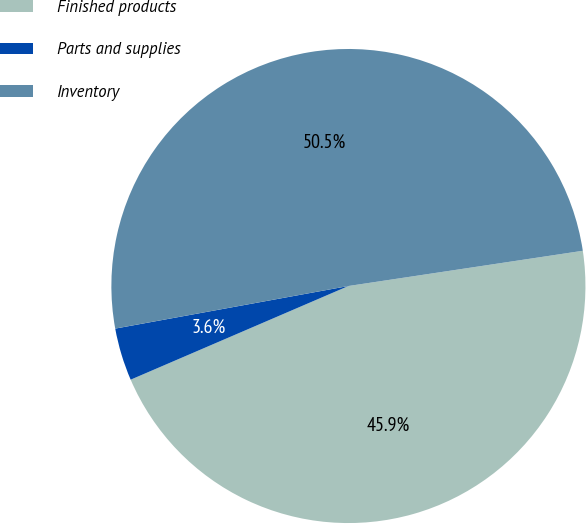<chart> <loc_0><loc_0><loc_500><loc_500><pie_chart><fcel>Finished products<fcel>Parts and supplies<fcel>Inventory<nl><fcel>45.91%<fcel>3.59%<fcel>50.5%<nl></chart> 